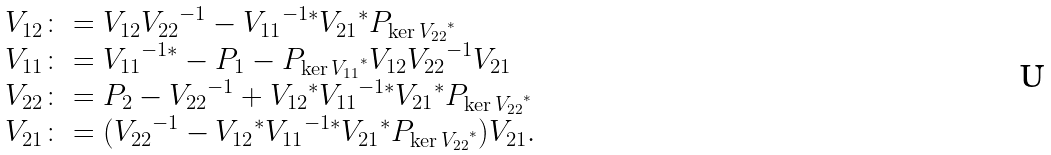<formula> <loc_0><loc_0><loc_500><loc_500>\begin{array} { l } \L V _ { 1 2 } \colon = V _ { 1 2 } { V _ { 2 2 } } ^ { - 1 } - { V _ { 1 1 } } ^ { - 1 * } { V _ { 2 1 } } ^ { * } P _ { { \ker V _ { 2 2 } } ^ { * } } \\ \L V _ { 1 1 } \colon = { V _ { 1 1 } } ^ { - 1 * } - P _ { 1 } - P _ { { \ker V _ { 1 1 } } ^ { * } } V _ { 1 2 } { V _ { 2 2 } } ^ { - 1 } V _ { 2 1 } \\ \L V _ { 2 2 } \colon = P _ { 2 } - { V _ { 2 2 } } ^ { - 1 } + { V _ { 1 2 } } ^ { * } { V _ { 1 1 } } ^ { - 1 * } { V _ { 2 1 } } ^ { * } P _ { { \ker V _ { 2 2 } } ^ { * } } \\ \L V _ { 2 1 } \colon = ( { V _ { 2 2 } } ^ { - 1 } - { V _ { 1 2 } } ^ { * } { V _ { 1 1 } } ^ { - 1 * } { V _ { 2 1 } } ^ { * } P _ { { \ker V _ { 2 2 } } ^ { * } } ) V _ { 2 1 } . \end{array}</formula> 